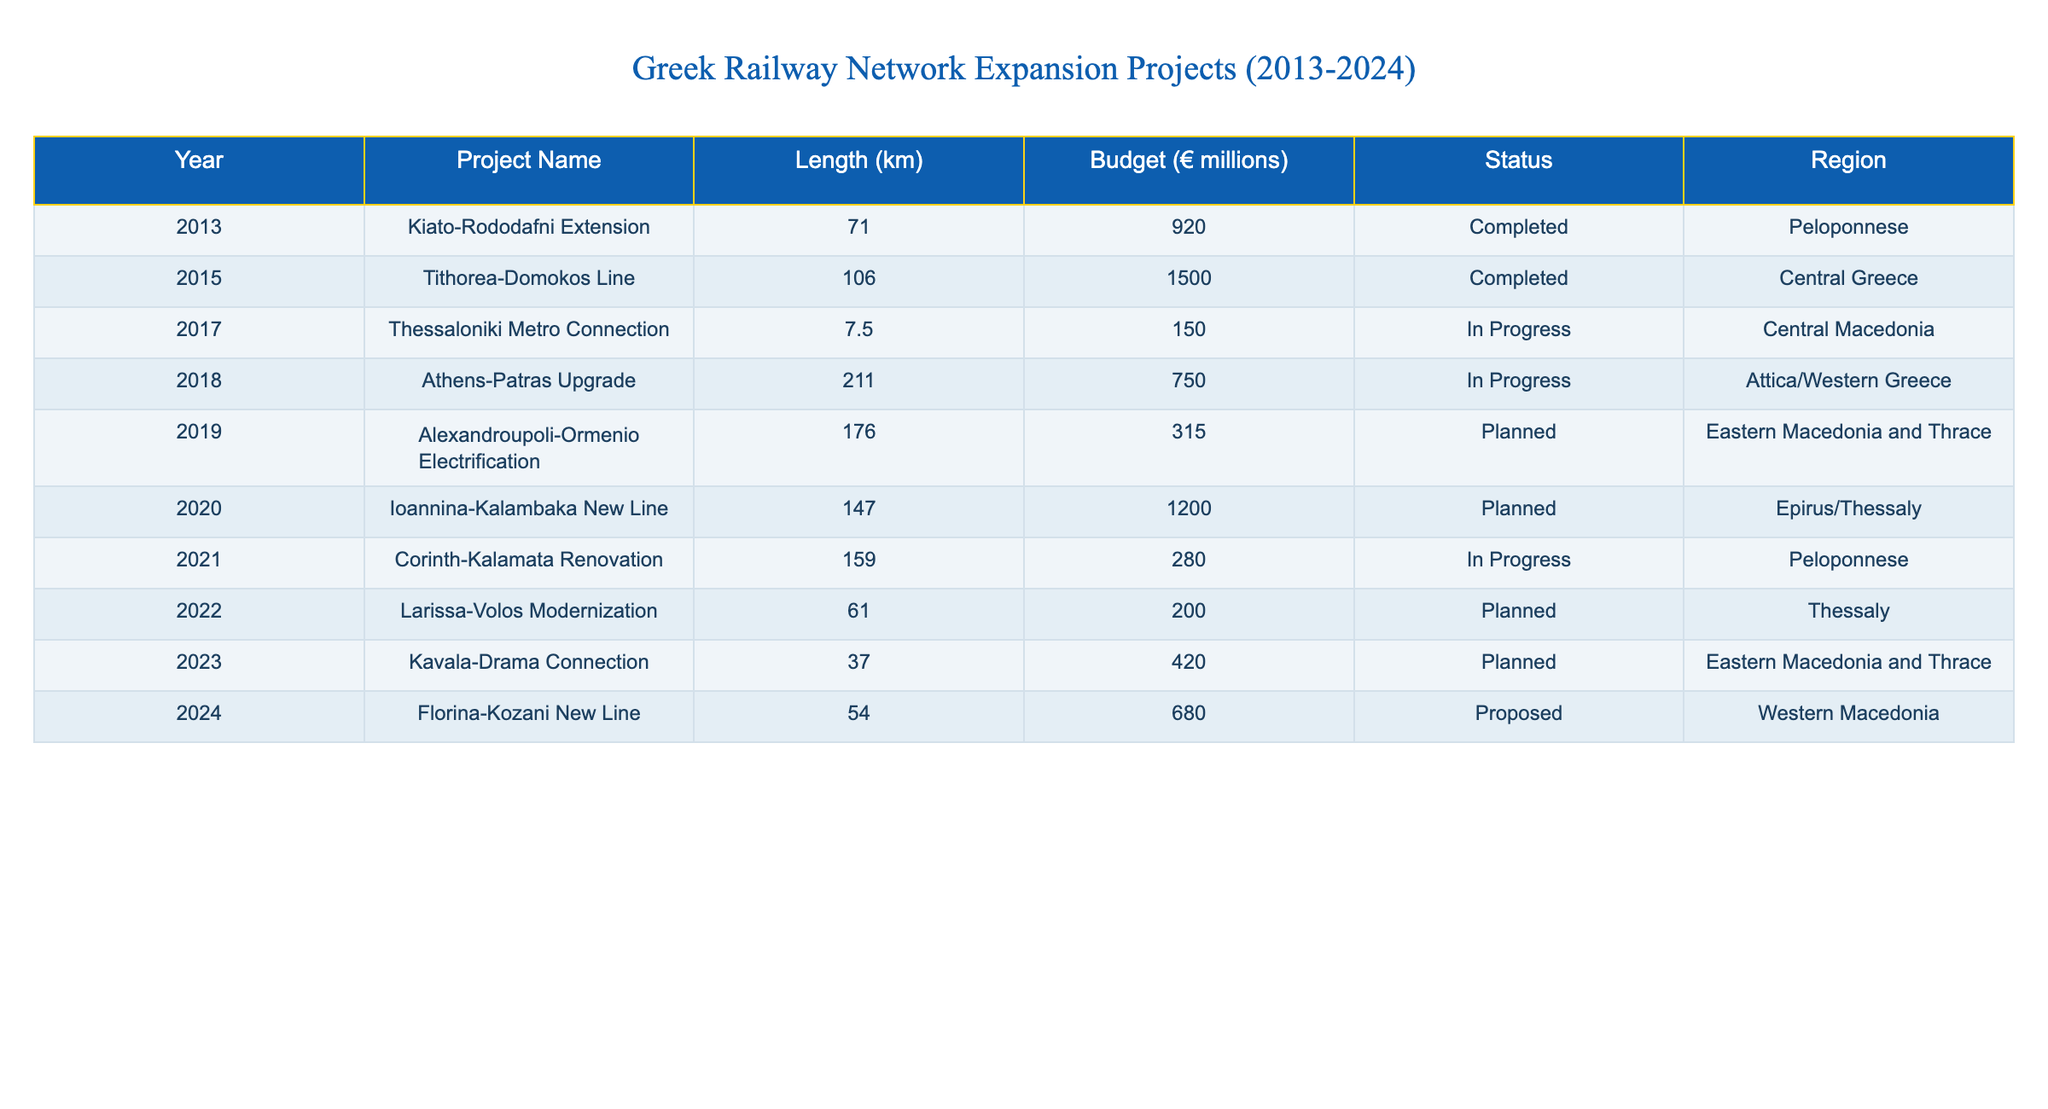What is the total length of all completed railway projects? From the table, we identify that the completed projects are "Kiato-Rododafni Extension" (71 km) and "Tithorea-Domokos Line" (106 km). Summing these lengths gives 71 + 106 = 177 km.
Answer: 177 km What is the budget for the Thessaloniki Metro Connection? The table lists the budget for the "Thessaloniki Metro Connection" project, which is 150 million euros.
Answer: 150 million euros How many projects are currently in progress? The projects in progress are "Thessaloniki Metro Connection," "Athens-Patras Upgrade," and "Corinth-Kalamata Renovation." Counting these gives us a total of 3 projects.
Answer: 3 What is the total budget of all planned projects? The planned projects and their budgets are "Alexandroupoli-Ormenio Electrification" (315 million euros), "Ioannina-Kalambaka New Line" (1200 million euros), "Larissa-Volos Modernization" (200 million euros), "Kavala-Drama Connection" (420 million euros), and "Florina-Kozani New Line" (680 million euros). Adding these budgets: 315 + 1200 + 200 + 420 + 680 = 2815 million euros.
Answer: 2815 million euros Is the "Athens-Patras Upgrade" project completed? The status of the "Athens-Patras Upgrade" is listed as 'In Progress,' indicating that it is not completed.
Answer: No Which region has the longest railway project and what is its length? The longest project is the "Athens-Patras Upgrade" at 211 km. Checking the projects by length shows that this is the maximum value.
Answer: 211 km What percentage of the total budget is allocated to completed projects? The total budget of completed projects (177 million euros) is compared to the total budget of all projects (920 + 1500 + 150 + 750 + 315 + 1200 + 280 + 200 + 420 + 680 = 5125 million euros). The percentage is (177/5125) x 100 which equals approximately 3.45%.
Answer: Approximately 3.45% Are there any projects planned in the Western Macedonia region? The table shows the "Florina-Kozani New Line" which is tagged as proposed in the Western Macedonia region. Thus, there is at least one planned project.
Answer: Yes How many projects have a budget over 400 million euros? The table indicates that the projects with budgets over 400 million euros are "Tithorea-Domokos Line" (1500 million euros), "Ioannina-Kalambaka New Line" (1200 million euros), "Athens-Patras Upgrade" (750 million euros), and "Kavala-Drama Connection" (420 million euros), totaling 4 projects.
Answer: 4 What is the average length of all railway projects listed in the table? The total length of all projects is 71 + 106 + 7.5 + 211 + 176 + 147 + 159 + 61 + 37 + 54 = 1,028. The total number of projects is 10. Thus, the average length is 1,028 / 10 = 102.8 km.
Answer: 102.8 km 